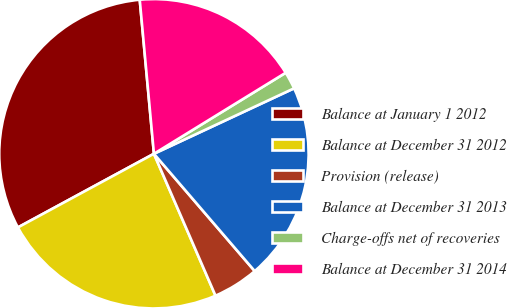Convert chart. <chart><loc_0><loc_0><loc_500><loc_500><pie_chart><fcel>Balance at January 1 2012<fcel>Balance at December 31 2012<fcel>Provision (release)<fcel>Balance at December 31 2013<fcel>Charge-offs net of recoveries<fcel>Balance at December 31 2014<nl><fcel>31.44%<fcel>23.62%<fcel>4.78%<fcel>20.66%<fcel>1.82%<fcel>17.69%<nl></chart> 